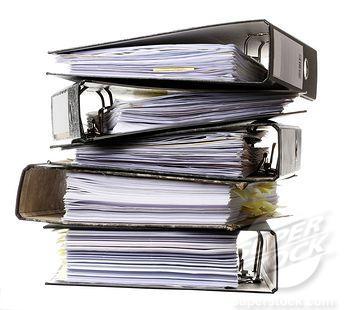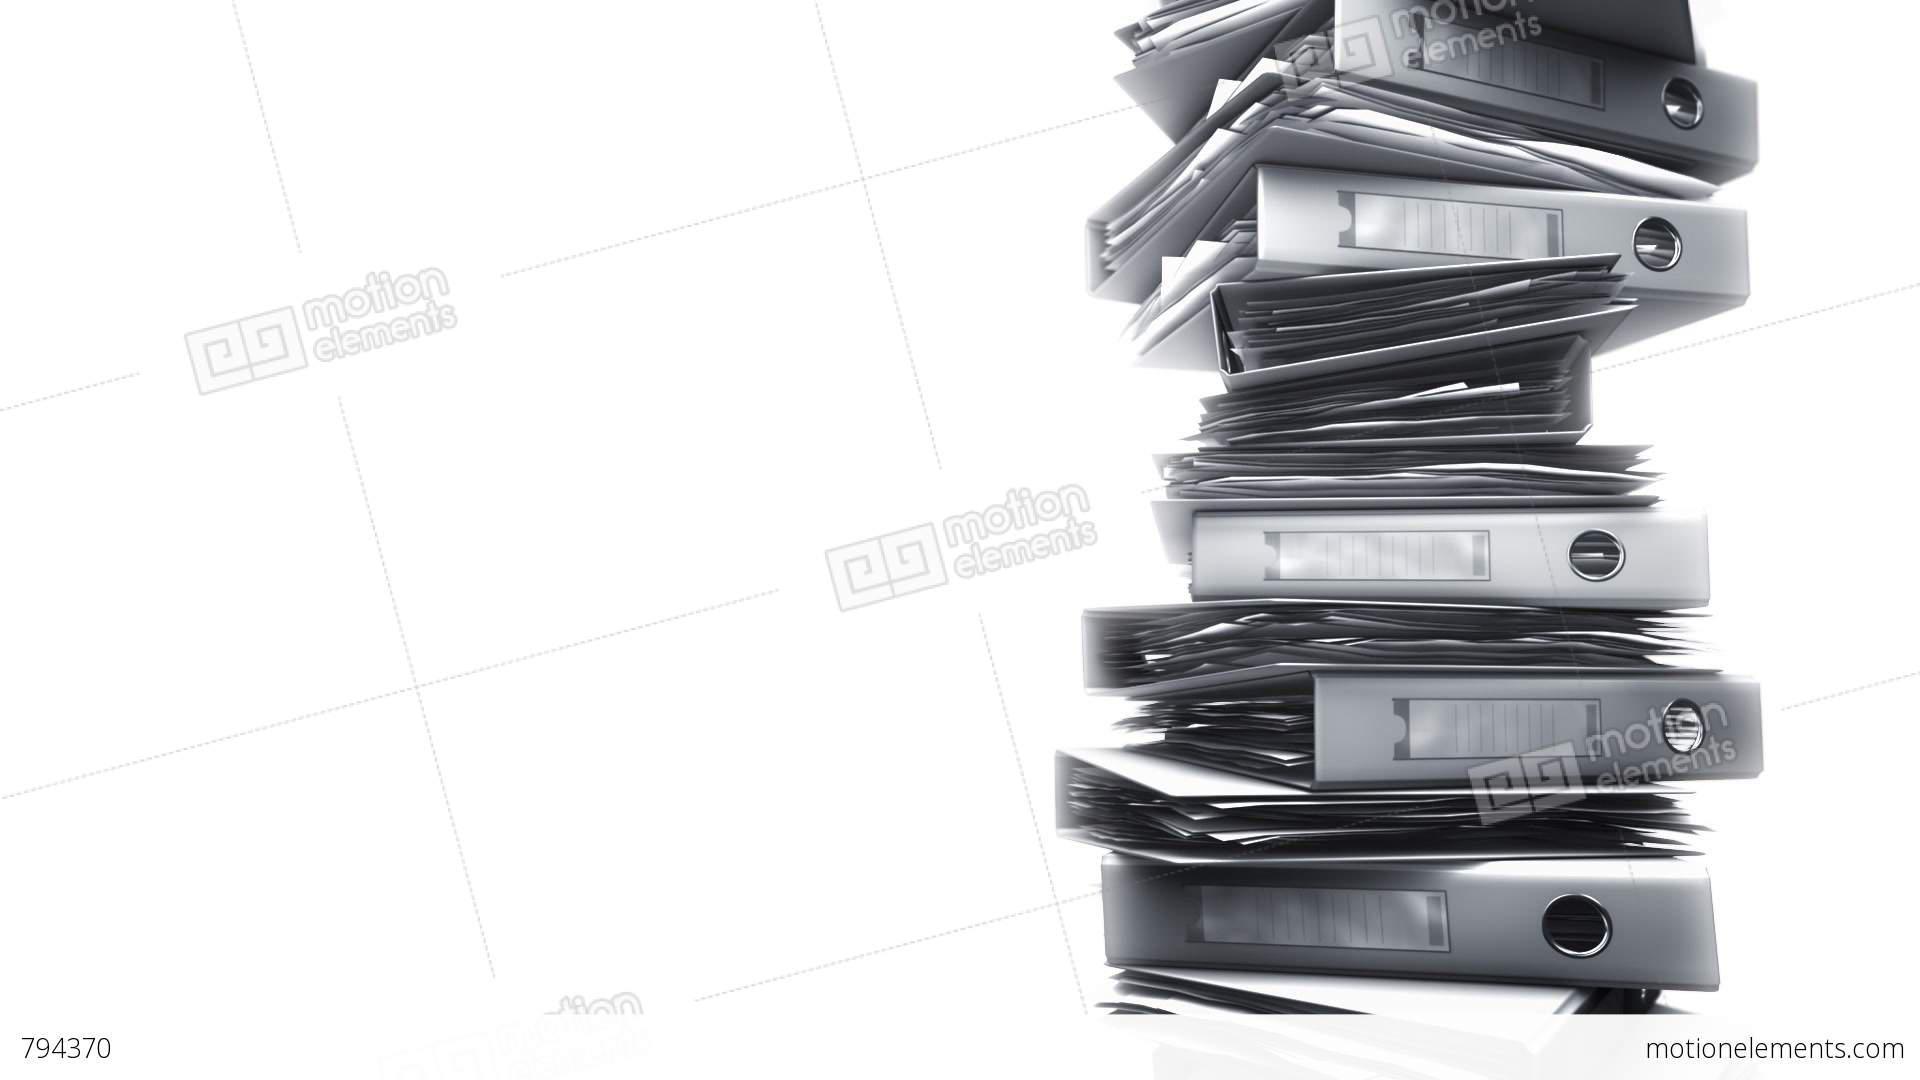The first image is the image on the left, the second image is the image on the right. Examine the images to the left and right. Is the description "The left image contains a person seated behind a stack of binders." accurate? Answer yes or no. No. The first image is the image on the left, the second image is the image on the right. Examine the images to the left and right. Is the description "A person is sitting behind a stack of binders in one of the images." accurate? Answer yes or no. No. 